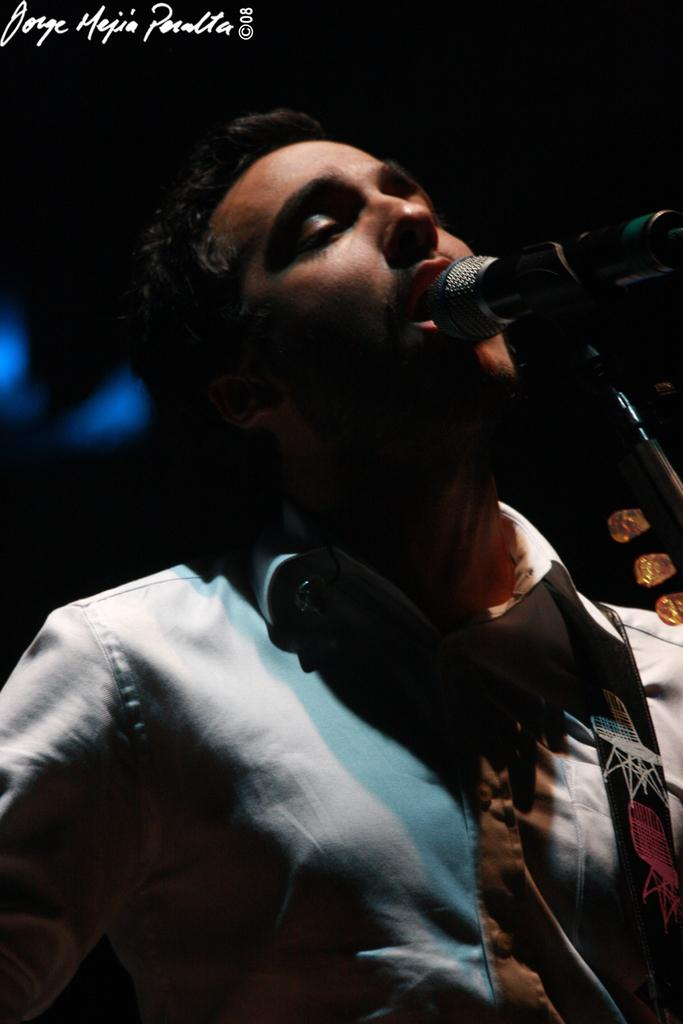Who is the main subject in the image? There is a person in the center of the image. What is the person doing in the image? The person is singing. What object is in front of the person? There is a microphone in front of the person. What type of sand can be seen in the background of the image? There is no sand present in the image; it features a person singing with a microphone in front of them. 